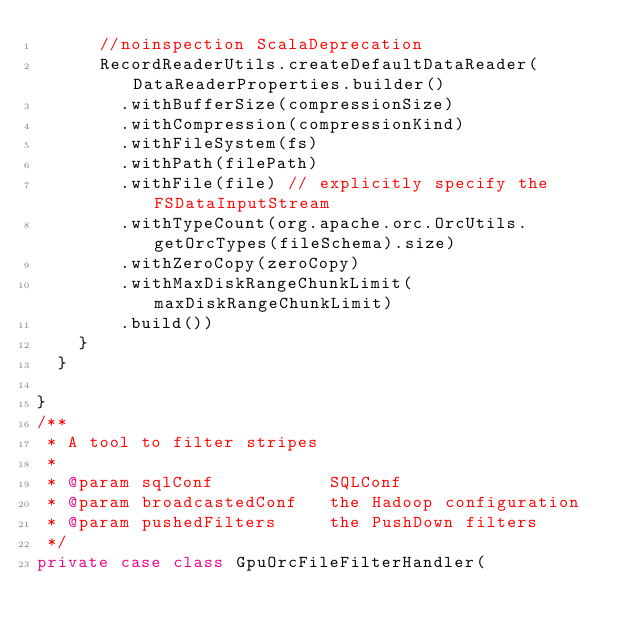Convert code to text. <code><loc_0><loc_0><loc_500><loc_500><_Scala_>      //noinspection ScalaDeprecation
      RecordReaderUtils.createDefaultDataReader(DataReaderProperties.builder()
        .withBufferSize(compressionSize)
        .withCompression(compressionKind)
        .withFileSystem(fs)
        .withPath(filePath)
        .withFile(file) // explicitly specify the FSDataInputStream
        .withTypeCount(org.apache.orc.OrcUtils.getOrcTypes(fileSchema).size)
        .withZeroCopy(zeroCopy)
        .withMaxDiskRangeChunkLimit(maxDiskRangeChunkLimit)
        .build())
    }
  }

}
/**
 * A tool to filter stripes
 *
 * @param sqlConf           SQLConf
 * @param broadcastedConf   the Hadoop configuration
 * @param pushedFilters     the PushDown filters
 */
private case class GpuOrcFileFilterHandler(</code> 